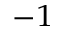<formula> <loc_0><loc_0><loc_500><loc_500>^ { - 1 }</formula> 